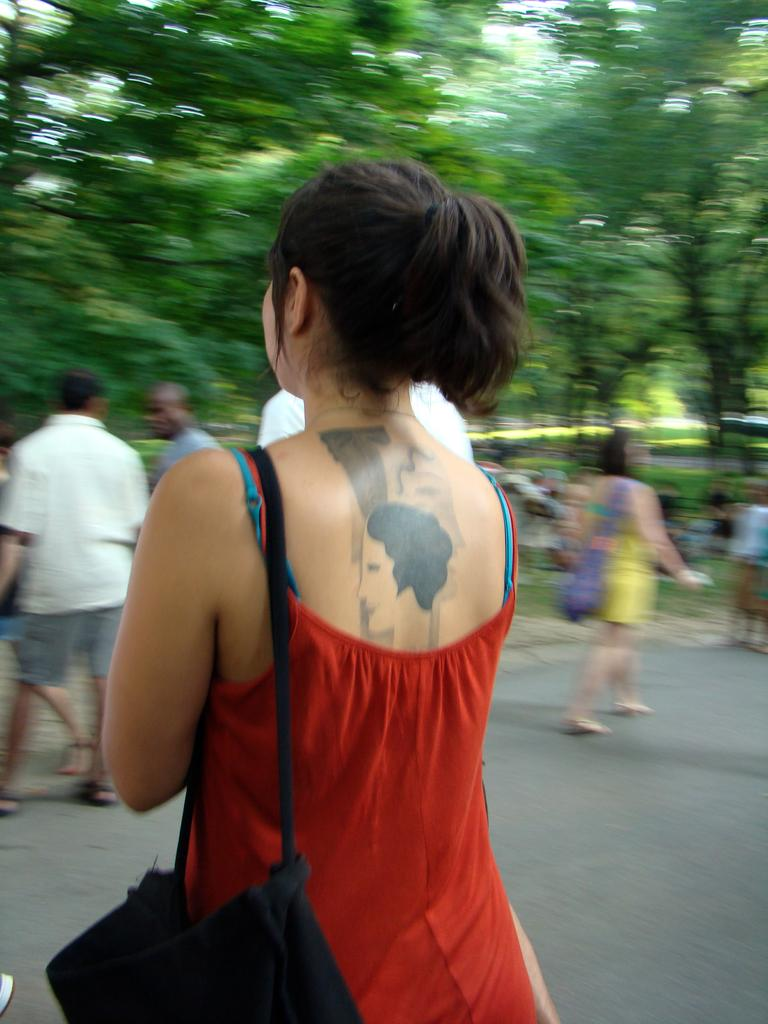What is the main subject of the image? There is a woman standing in the center of the image. What is the woman holding in the image? The woman is holding a handbag. What can be seen in the background of the image? There are trees, a road, and grass visible in the background of the image. Are there any other people in the image besides the woman? Yes, there are people walking on the road in the background of the image. Can you see a pig playing with a thumb in the image? No, there is no pig or thumb present in the image. Is there a stream visible in the image? No, there is no stream visible in the image; only trees, a road, and grass are present in the background. 